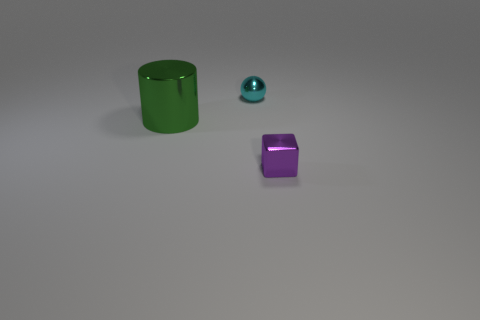What number of metal things are big cylinders or purple things?
Offer a terse response. 2. Are the object that is behind the big cylinder and the small object on the right side of the cyan thing made of the same material?
Give a very brief answer. Yes. Is there a green matte cylinder?
Your response must be concise. No. Does the small metal thing behind the large green metal thing have the same shape as the small shiny thing in front of the big green object?
Offer a terse response. No. Is there a tiny purple thing that has the same material as the small cube?
Make the answer very short. No. Is the small object behind the small purple metallic block made of the same material as the purple block?
Offer a very short reply. Yes. Is the number of small purple shiny things that are on the left side of the tiny cyan shiny sphere greater than the number of green cylinders that are to the left of the green shiny thing?
Offer a very short reply. No. What color is the other shiny thing that is the same size as the cyan metal object?
Ensure brevity in your answer.  Purple. Are there any large rubber cylinders of the same color as the small ball?
Make the answer very short. No. There is a tiny metallic thing right of the metal sphere; is its color the same as the shiny thing behind the cylinder?
Provide a succinct answer. No. 